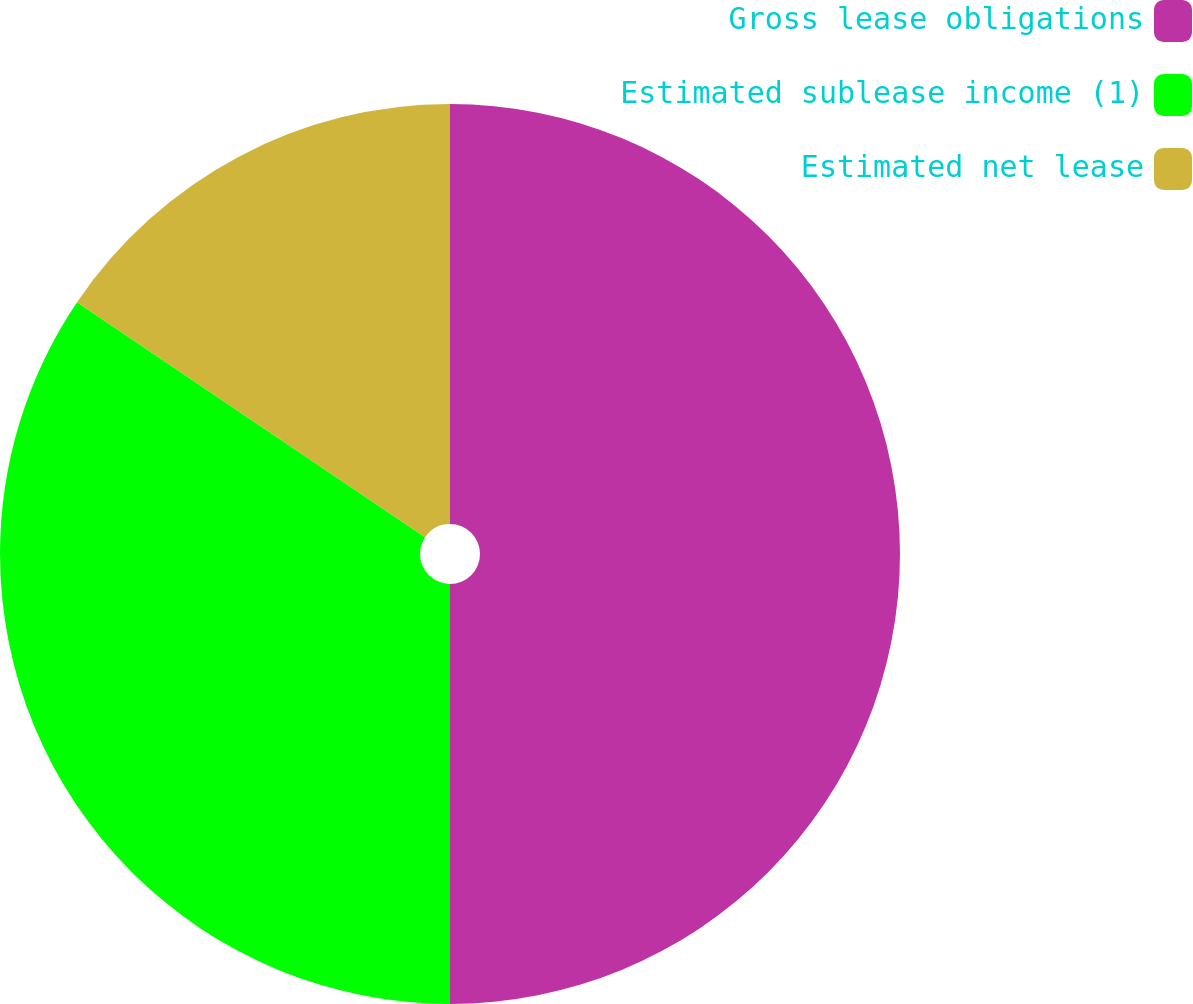Convert chart. <chart><loc_0><loc_0><loc_500><loc_500><pie_chart><fcel>Gross lease obligations<fcel>Estimated sublease income (1)<fcel>Estimated net lease<nl><fcel>50.0%<fcel>34.45%<fcel>15.55%<nl></chart> 